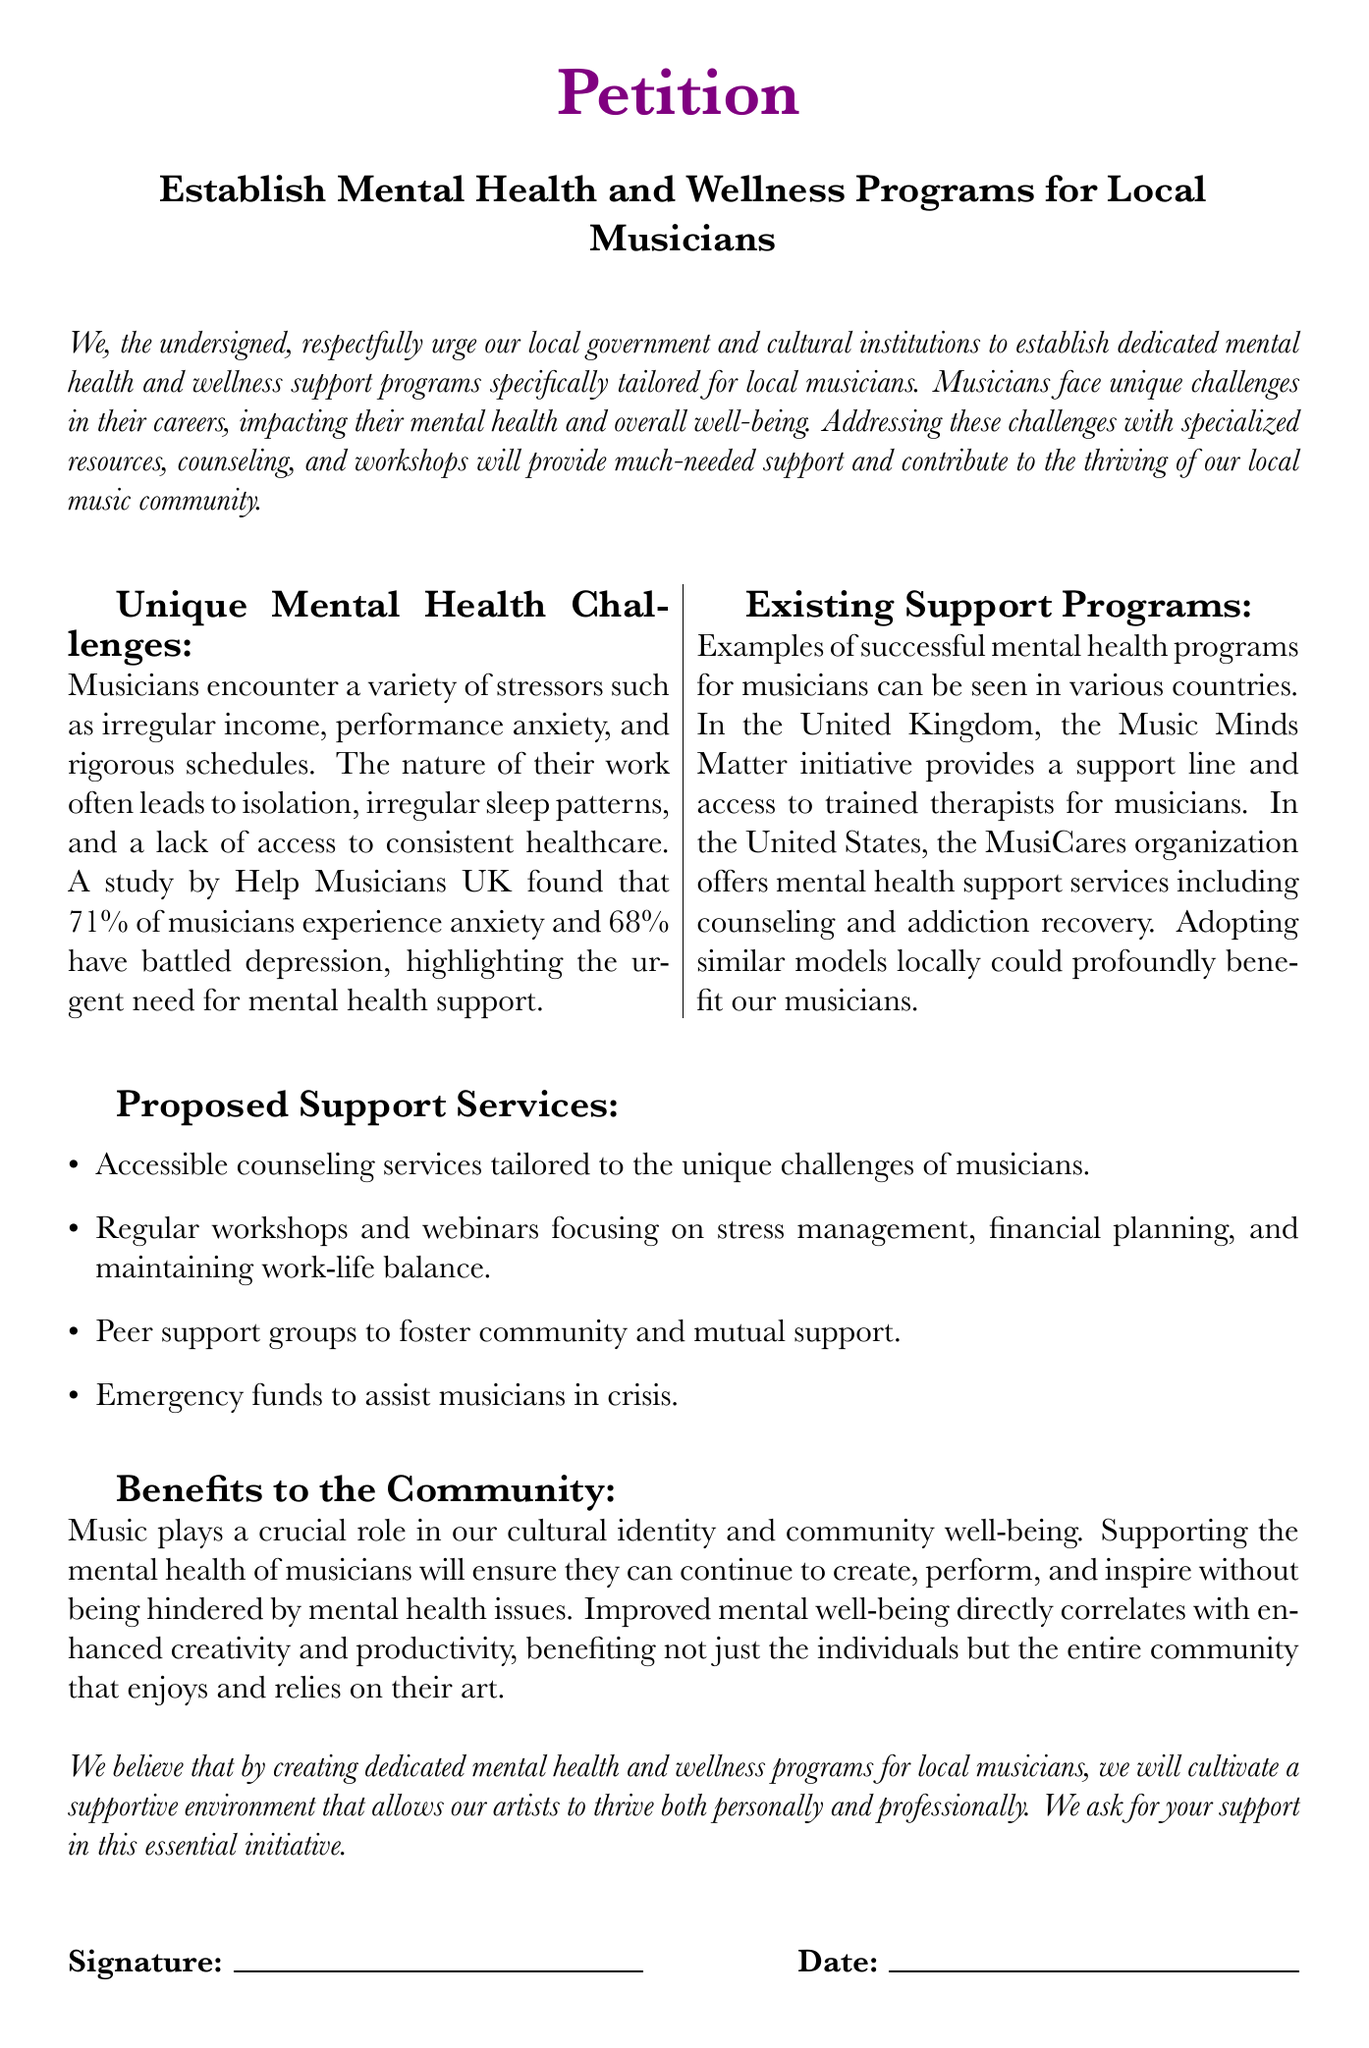What is the title of the petition? The title of the petition is found in the document and emphasizes the establishment of mental health and wellness support programs for local musicians.
Answer: Establish Mental Health and Wellness Programs for Local Musicians What percentage of musicians experience anxiety according to the study? The document states that a study found that 71% of musicians experience anxiety, providing specific evidence for the need for mental health support.
Answer: 71% What are two proposed support services mentioned in the document? The document lists several proposed services aimed at aiding musicians, asking for a brief identification of two among them.
Answer: Accessible counseling services, regular workshops What is the primary benefit of supporting musicians' mental health mentioned in the document? The document articulates that improved mental well-being directly contributes to enhanced creativity and productivity, explaining its significance to the community.
Answer: Enhanced creativity and productivity Which organization in the United States is mentioned as providing mental health support services? The document references a specific organization known for offering mental health support services for musicians in the United States, highlighting existing models.
Answer: MusiCares What unique challenges do musicians face according to the petition? The document discusses various unique stressors faced by musicians, asking for an identification of these challenges presented in the text.
Answer: Irregular income, performance anxiety, isolation What type of community support is proposed through peer support groups? The document mentions peer support groups as a method for fostering a specific type of beneficial community connection for musicians, requiring identification.
Answer: Community and mutual support On what day is the date line specified for signatures? The document includes space for recording the date related to signature signing, hinting at the procedural aspect of petitions.
Answer: Date 